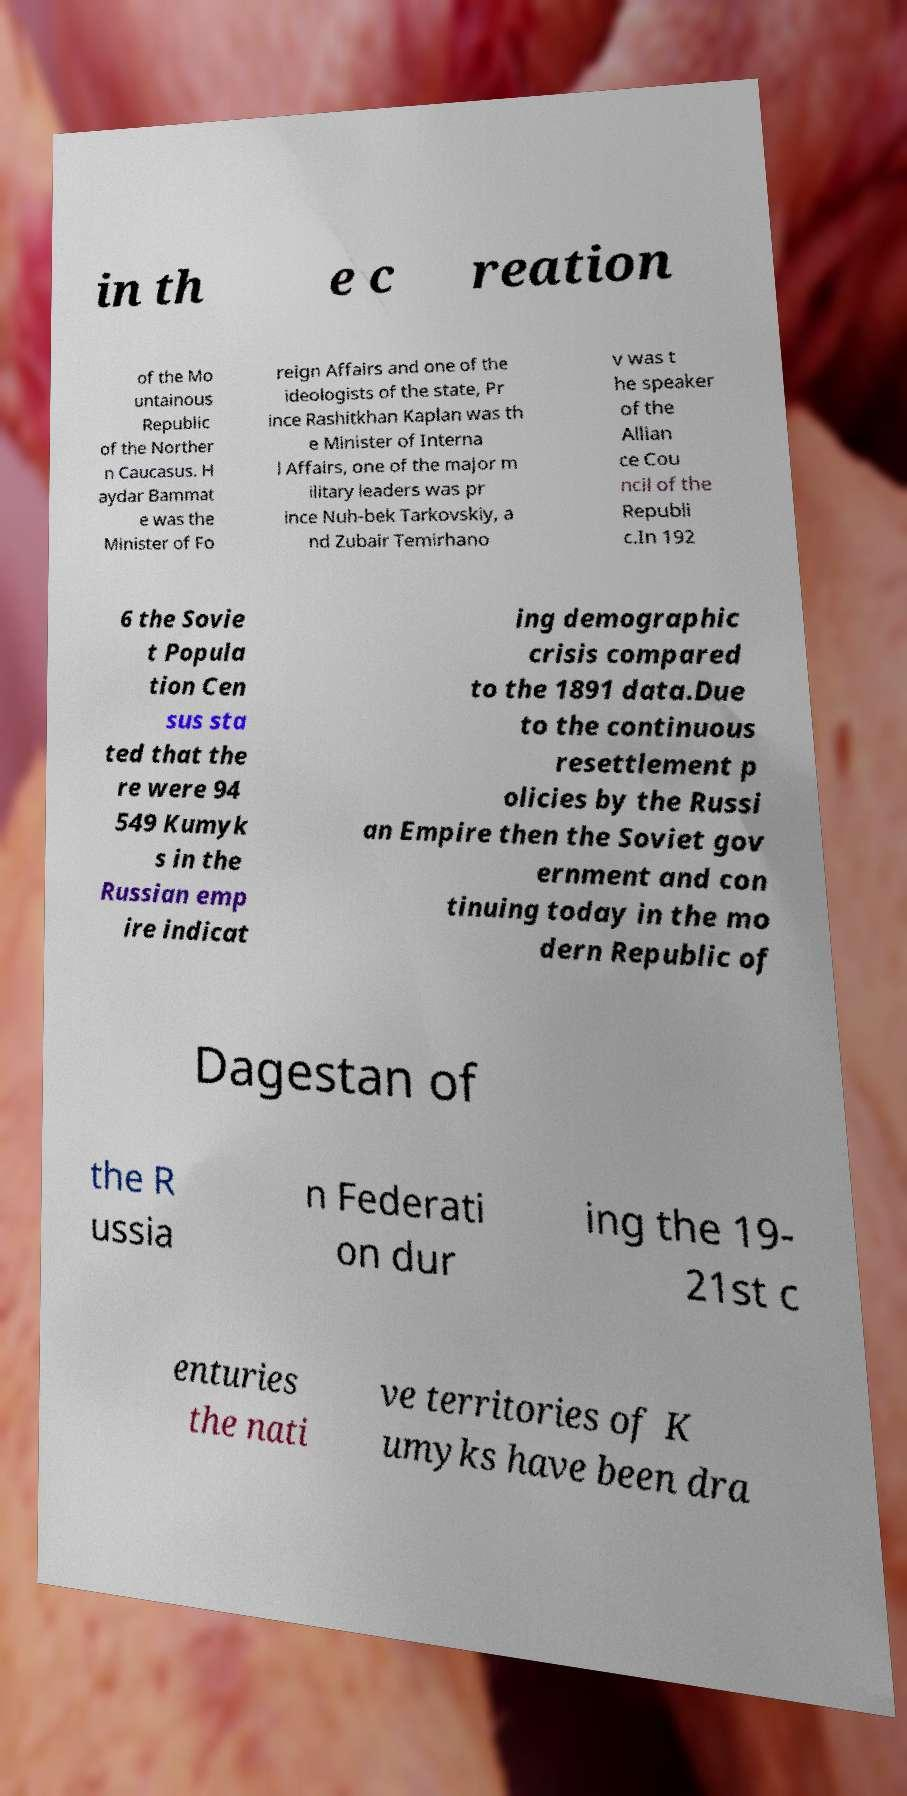What messages or text are displayed in this image? I need them in a readable, typed format. in th e c reation of the Mo untainous Republic of the Norther n Caucasus. H aydar Bammat e was the Minister of Fo reign Affairs and one of the ideologists of the state, Pr ince Rashitkhan Kaplan was th e Minister of Interna l Affairs, one of the major m ilitary leaders was pr ince Nuh-bek Tarkovskiy, a nd Zubair Temirhano v was t he speaker of the Allian ce Cou ncil of the Republi c.In 192 6 the Sovie t Popula tion Cen sus sta ted that the re were 94 549 Kumyk s in the Russian emp ire indicat ing demographic crisis compared to the 1891 data.Due to the continuous resettlement p olicies by the Russi an Empire then the Soviet gov ernment and con tinuing today in the mo dern Republic of Dagestan of the R ussia n Federati on dur ing the 19- 21st c enturies the nati ve territories of K umyks have been dra 